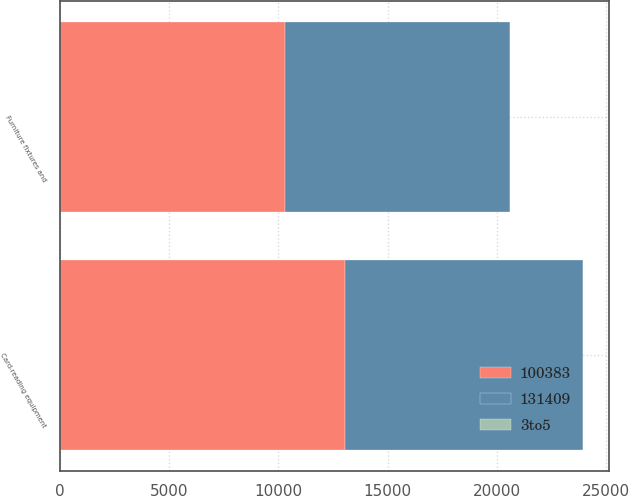Convert chart to OTSL. <chart><loc_0><loc_0><loc_500><loc_500><stacked_bar_chart><ecel><fcel>Card-reading equipment<fcel>Furniture fixtures and<nl><fcel>3to5<fcel>5<fcel>5<nl><fcel>131409<fcel>10887<fcel>10291<nl><fcel>100383<fcel>13066<fcel>10319<nl></chart> 